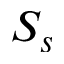<formula> <loc_0><loc_0><loc_500><loc_500>S _ { s }</formula> 